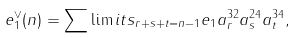<formula> <loc_0><loc_0><loc_500><loc_500>e _ { 1 } ^ { \vee } ( n ) = \sum \lim i t s _ { r + s + t = n - 1 } { e _ { 1 } { a } _ { r } ^ { 3 2 } { a } _ { s } ^ { 2 4 } { a } _ { t } ^ { 3 4 } } ,</formula> 